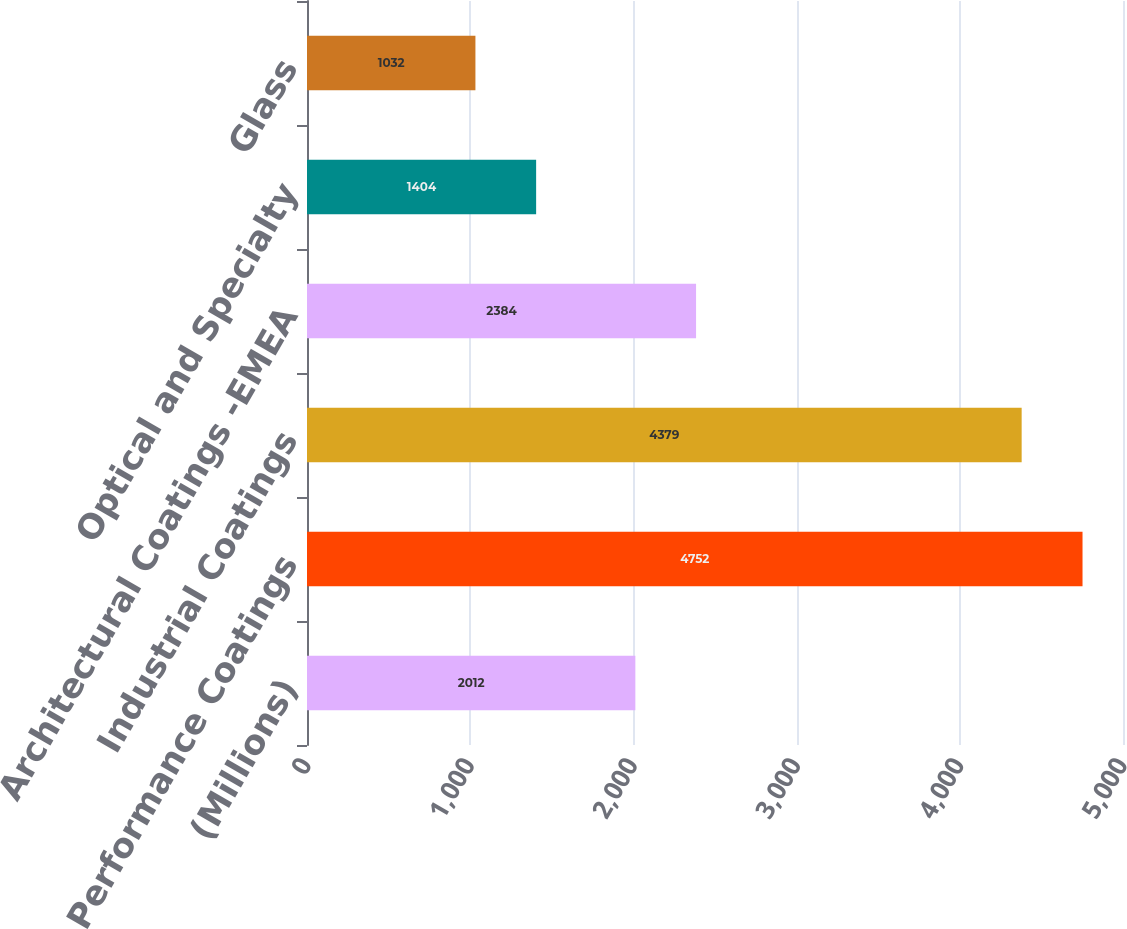Convert chart. <chart><loc_0><loc_0><loc_500><loc_500><bar_chart><fcel>(Millions)<fcel>Performance Coatings<fcel>Industrial Coatings<fcel>Architectural Coatings -EMEA<fcel>Optical and Specialty<fcel>Glass<nl><fcel>2012<fcel>4752<fcel>4379<fcel>2384<fcel>1404<fcel>1032<nl></chart> 